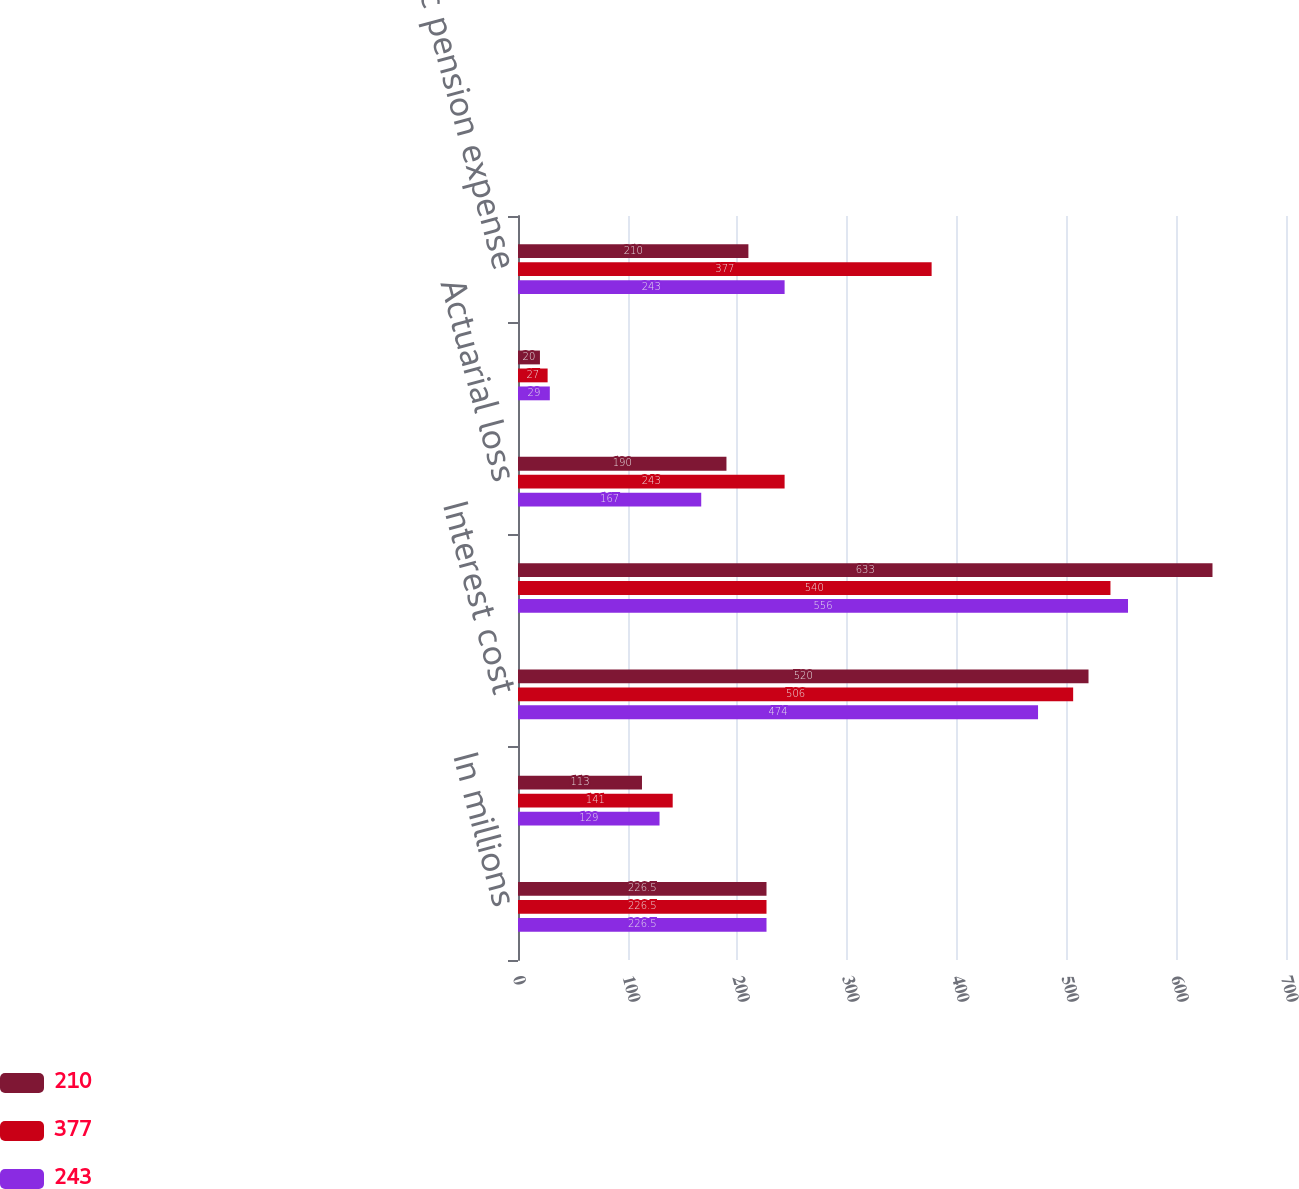<chart> <loc_0><loc_0><loc_500><loc_500><stacked_bar_chart><ecel><fcel>In millions<fcel>Service cost<fcel>Interest cost<fcel>Expectedreturnonplanassets<fcel>Actuarial loss<fcel>Amortization of prior service<fcel>Net periodic pension expense<nl><fcel>210<fcel>226.5<fcel>113<fcel>520<fcel>633<fcel>190<fcel>20<fcel>210<nl><fcel>377<fcel>226.5<fcel>141<fcel>506<fcel>540<fcel>243<fcel>27<fcel>377<nl><fcel>243<fcel>226.5<fcel>129<fcel>474<fcel>556<fcel>167<fcel>29<fcel>243<nl></chart> 